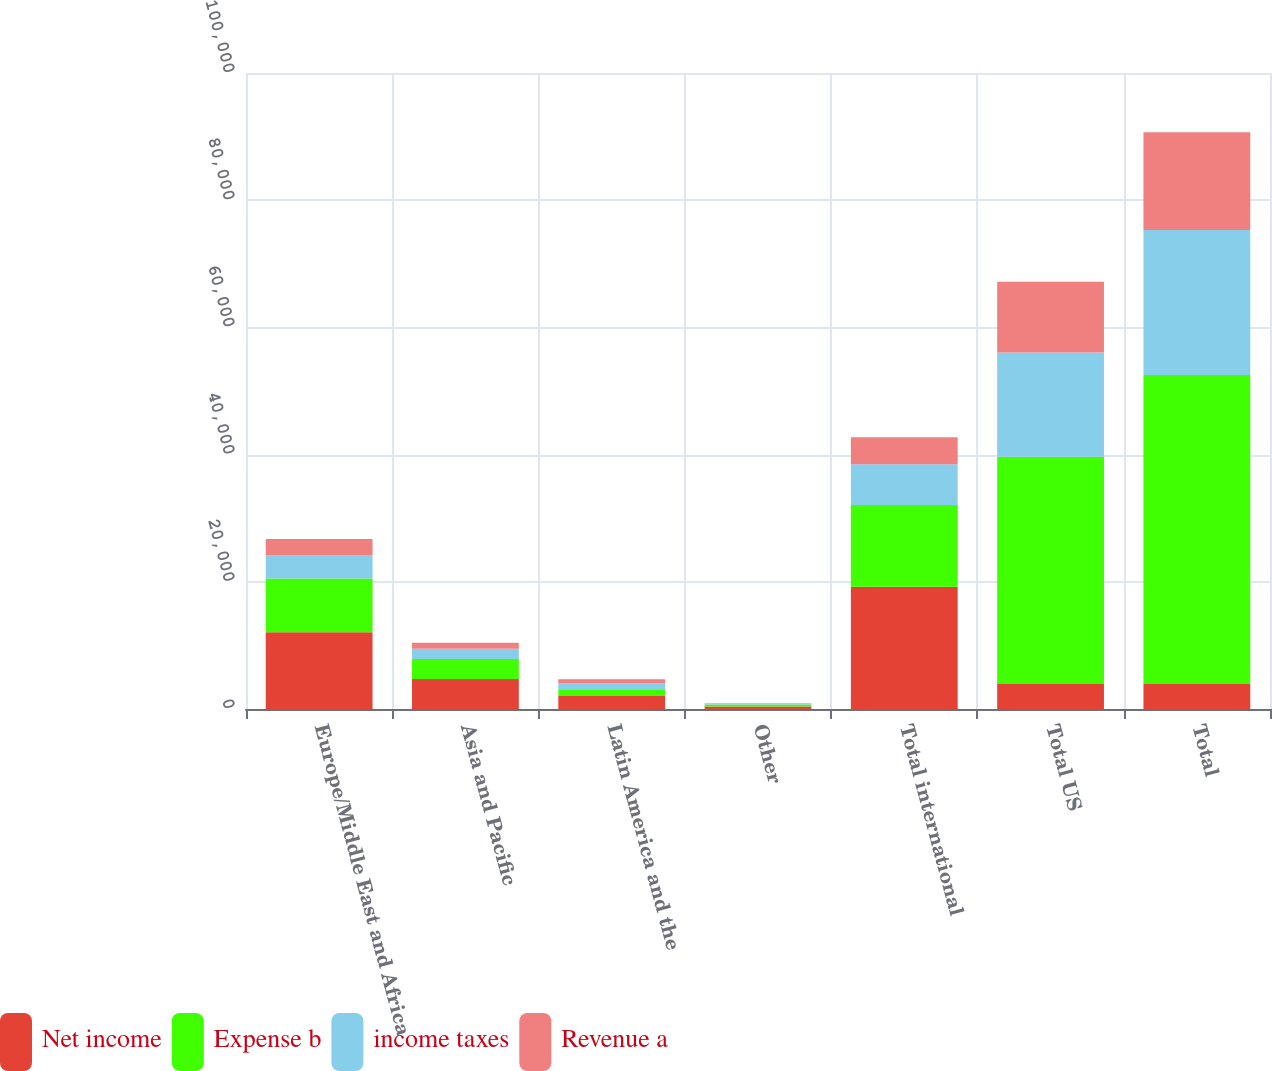<chart> <loc_0><loc_0><loc_500><loc_500><stacked_bar_chart><ecel><fcel>Europe/Middle East and Africa<fcel>Asia and Pacific<fcel>Latin America and the<fcel>Other<fcel>Total international<fcel>Total US<fcel>Total<nl><fcel>Net income<fcel>12070<fcel>4730<fcel>2028<fcel>407<fcel>19235<fcel>3932<fcel>3932<nl><fcel>Expense b<fcel>8445<fcel>3117<fcel>975<fcel>289<fcel>12826<fcel>35741<fcel>48567<nl><fcel>income taxes<fcel>3625<fcel>1613<fcel>1053<fcel>118<fcel>6409<fcel>16396<fcel>22805<nl><fcel>Revenue a<fcel>2585<fcel>945<fcel>630<fcel>79<fcel>4239<fcel>11126<fcel>15365<nl></chart> 